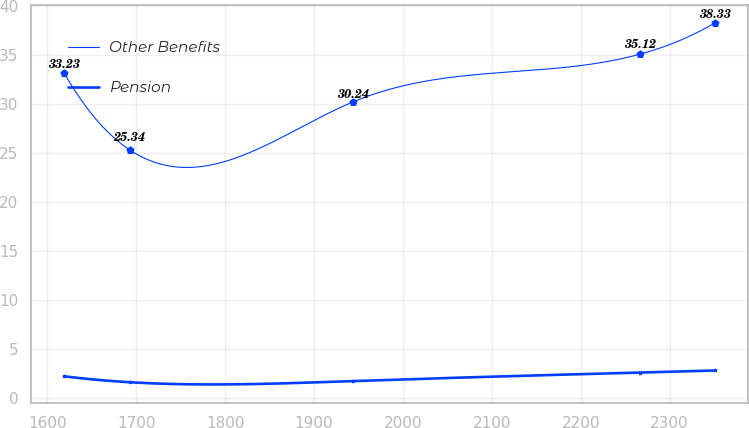Convert chart. <chart><loc_0><loc_0><loc_500><loc_500><line_chart><ecel><fcel>Other Benefits<fcel>Pension<nl><fcel>1618.63<fcel>33.23<fcel>2.23<nl><fcel>1692.68<fcel>25.34<fcel>1.62<nl><fcel>1943.79<fcel>30.24<fcel>1.74<nl><fcel>2266.92<fcel>35.12<fcel>2.61<nl><fcel>2351.43<fcel>38.33<fcel>2.82<nl></chart> 